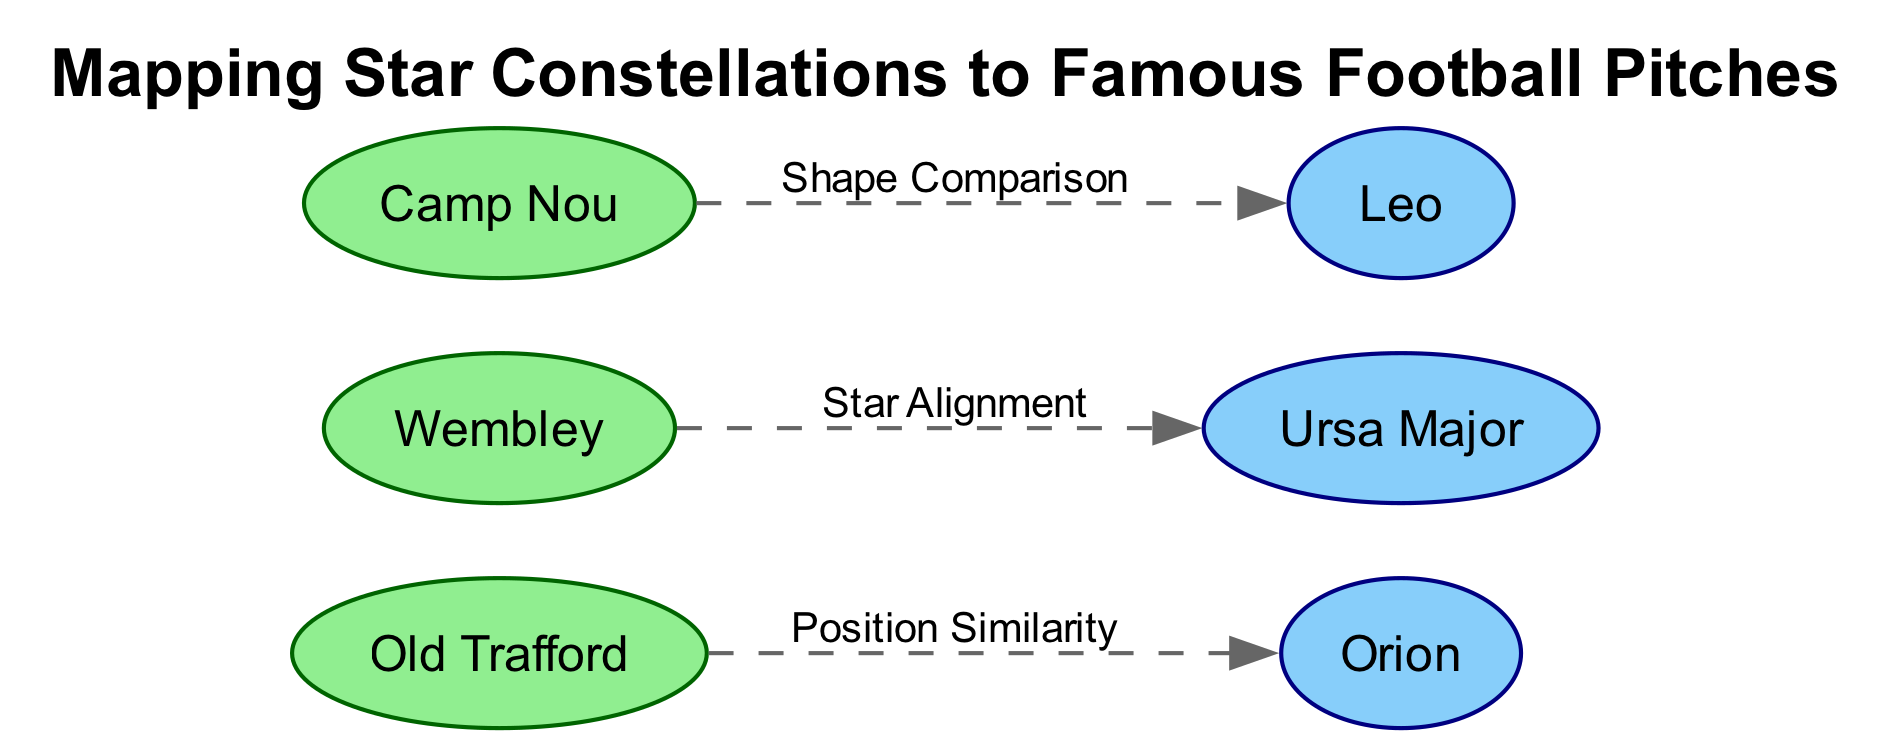What are the names of the football pitches depicted in the diagram? The diagram features three pitches: Old Trafford, Wembley, and Camp Nou. This can be identified by looking at the nodes labeled as "pitch".
Answer: Old Trafford, Wembley, Camp Nou How many constellations are represented in the diagram? The diagram presents three constellations: Orion, Ursa Major, and Leo. By counting the nodes labeled as "constellation", it's clear there are three.
Answer: 3 Which constellation is connected to Old Trafford? The edge labeled "Position Similarity" connects Old Trafford to the constellation Orion. Since the edges represent relationships and the labels indicate the connections, this relationship is straightforward.
Answer: Orion What type of relationship exists between Wembley and Ursa Major? The relationship between Wembley and Ursa Major is described as "Star Alignment". This is specified in the edge connecting these two nodes, indicating the type of interaction or similarity noticed in the diagram.
Answer: Star Alignment Which constellation shares a shape comparison with Camp Nou? The diagram shows that Camp Nou has a shape comparison with the constellation Leo, as indicated by the corresponding edge label. Thus, the answer is derived directly from the labeled edge.
Answer: Leo Which pitch has a connection to the constellation that lies in the classic "Three Stars" alignment? Old Trafford is connected to Orion, which is often depicted with the classic "Three Stars" pattern in its belt. This requires recalling the typical star pattern associated with the constellation, making this reasoning slightly more involved.
Answer: Old Trafford If there are three edges in the diagram, how many relationships connect the pitches to the constellations? Each edge represents a distinct relationship between a pitch and a constellation; therefore, since there are three edges shown, all connecting to different constellations, the total number of connections is 3.
Answer: 3 What type of diagram is this? The title and the structure of the diagram directly indicate it is an "Astronomy Diagram" since it maps stars and constellations to football pitches, incorporating elements from both fields.
Answer: Astronomy Diagram Which constellation is visually aligned with Wembley? The constellation visually aligned with Wembley is Ursa Major, as indicated by the directed edge that specifically describes this relationship in the diagram.
Answer: Ursa Major 